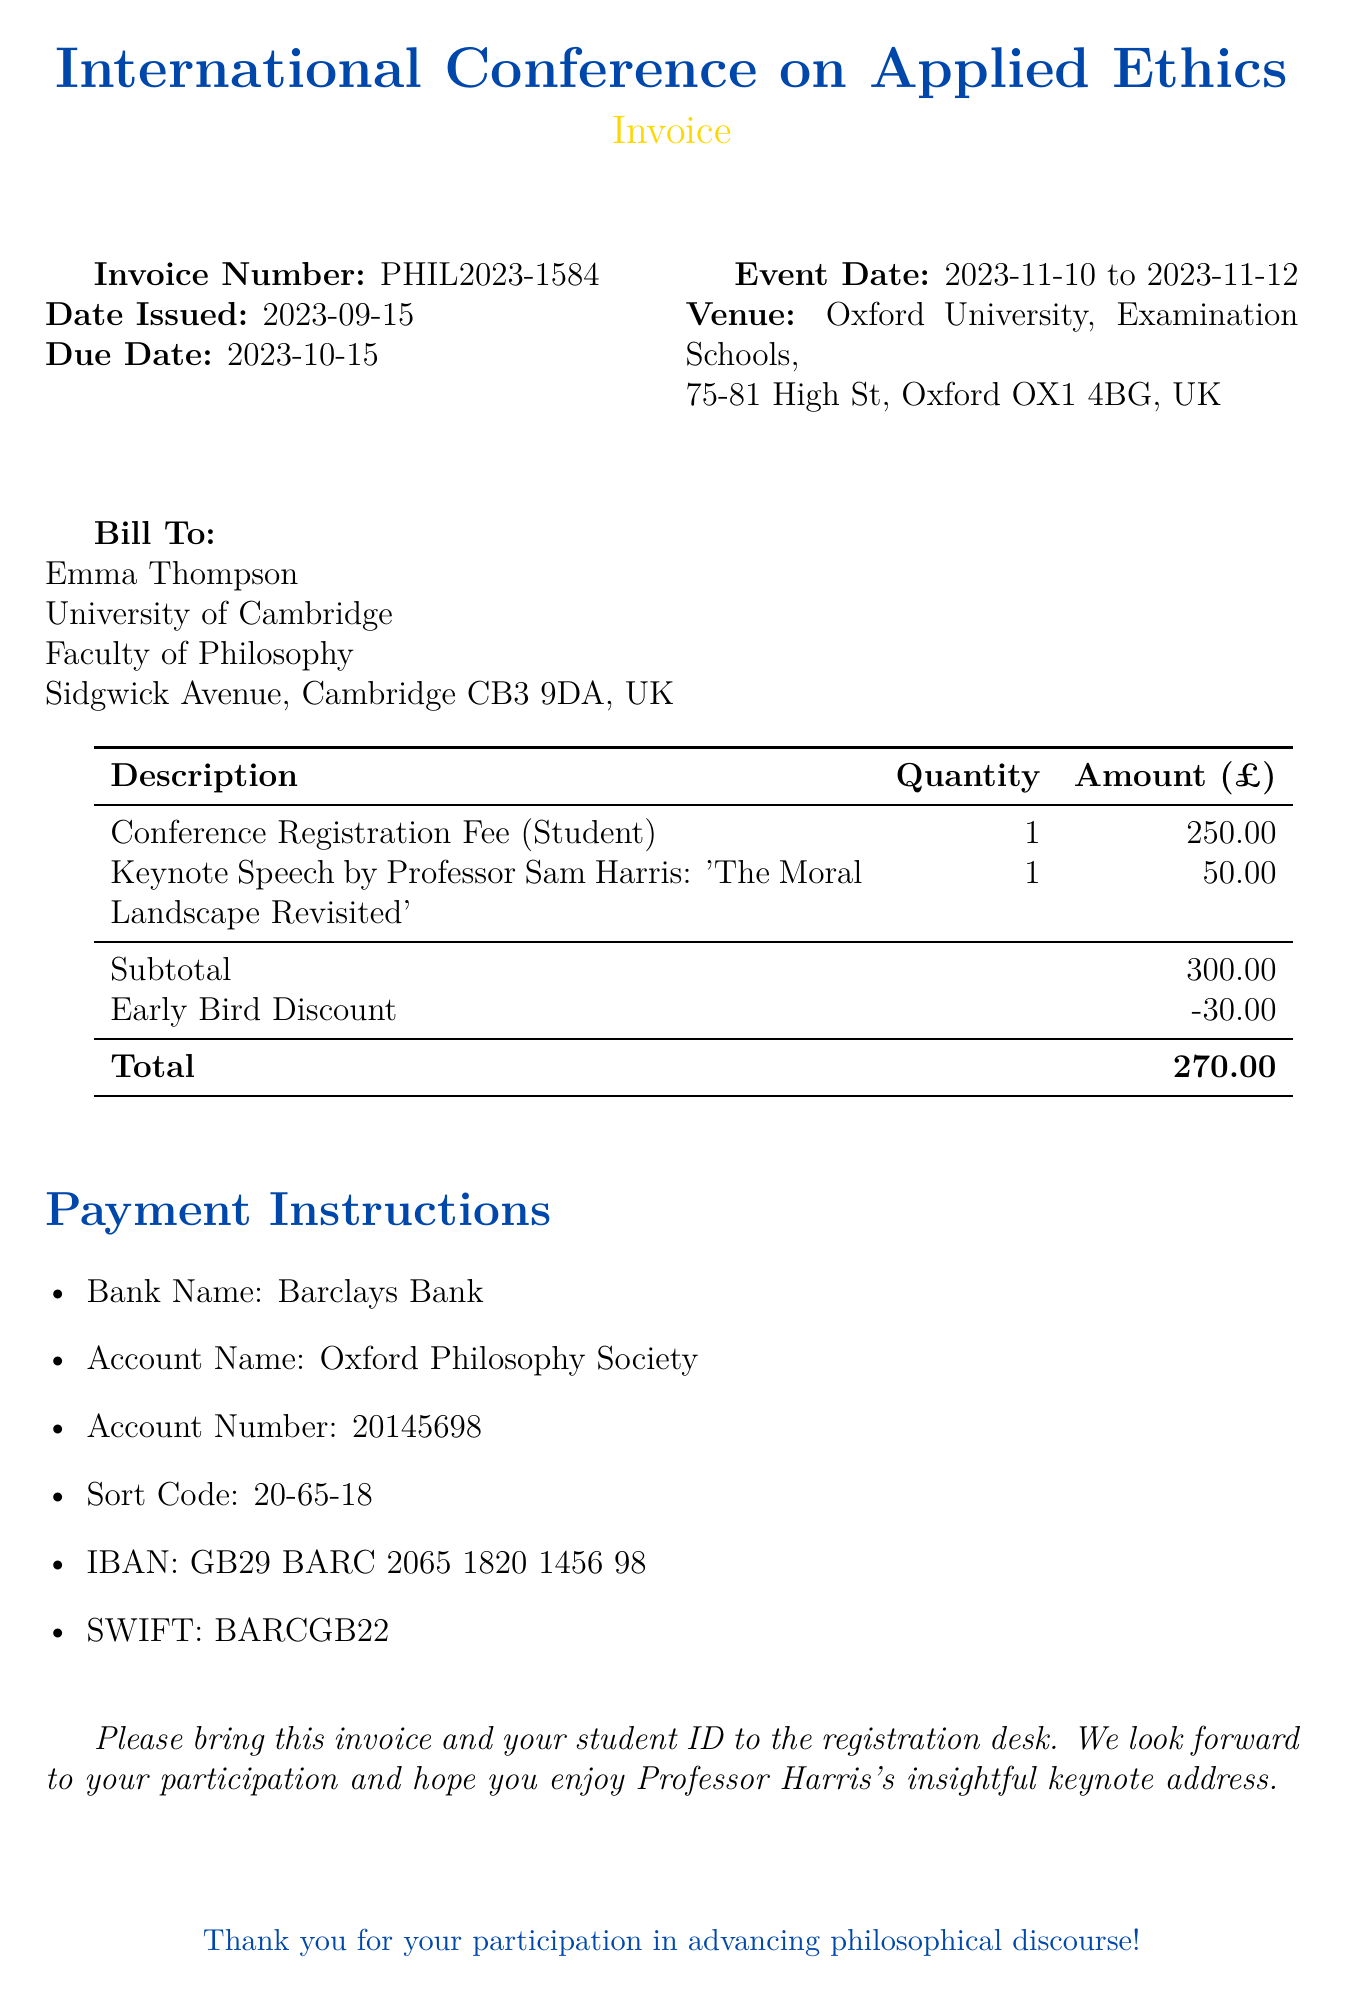What is the invoice number? The invoice number is specified in the document as PHIL2023-1584.
Answer: PHIL2023-1584 What is the total amount due? The total amount due is listed at the end of the invoice after applying the early bird discount.
Answer: 270.00 Who is the keynote speaker? The keynote speaker is mentioned in the description section of the invoice.
Answer: Professor Sam Harris What is the venue for the conference? The venue is specified in the document under the event details section.
Answer: Oxford University, Examination Schools When is the early bird discount applied? The early bird discount is indicated in the subtotals section of the invoice, showing the reduced price.
Answer: 30.00 Which university does the bill go to? The bill is addressed to a specific individual and their affiliated institution, which is indicated in the "Bill To" section.
Answer: University of Cambridge What is the event start date? The event start date can be derived from the event date information provided in the document.
Answer: 2023-11-10 What is the account number for payment? The account number is detailed in the payment instructions.
Answer: 20145698 